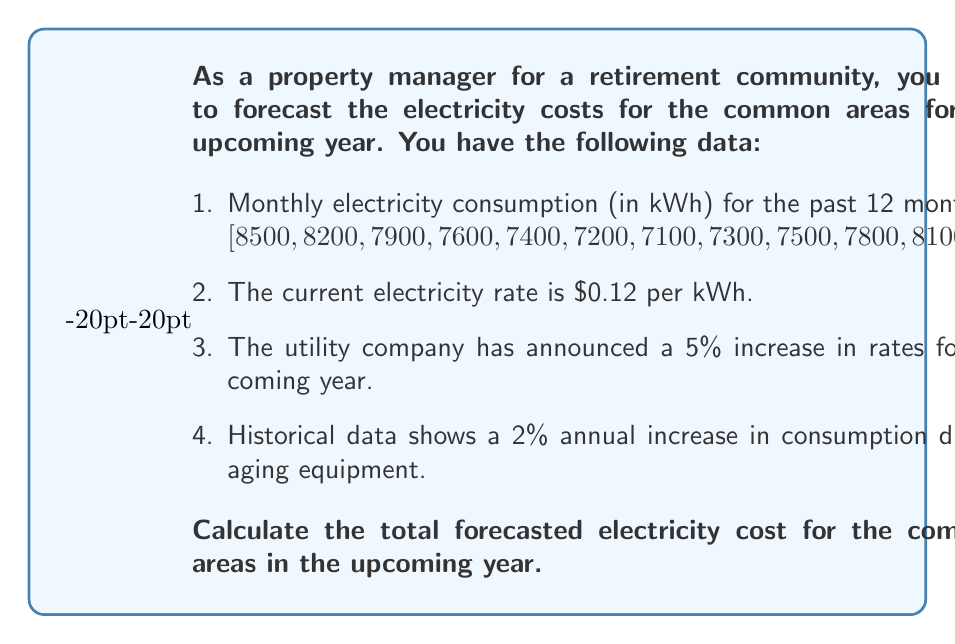Could you help me with this problem? To solve this problem, we'll follow these steps:

1. Calculate the total annual consumption based on the given data.
2. Apply the 2% increase in consumption for the upcoming year.
3. Calculate the new electricity rate after the 5% increase.
4. Compute the total forecasted cost.

Step 1: Calculate the total annual consumption
Total consumption = $\sum_{i=1}^{12} \text{Monthly consumption}_i$
$$ \text{Total consumption} = 8500 + 8200 + 7900 + 7600 + 7400 + 7200 + 7100 + 7300 + 7500 + 7800 + 8100 + 8400 = 93,000 \text{ kWh} $$

Step 2: Apply the 2% increase in consumption
New annual consumption = Current consumption × (1 + 0.02)
$$ \text{New annual consumption} = 93,000 \times 1.02 = 94,860 \text{ kWh} $$

Step 3: Calculate the new electricity rate
New rate = Current rate × (1 + 0.05)
$$ \text{New rate} = \$0.12 \times 1.05 = \$0.126 \text{ per kWh} $$

Step 4: Compute the total forecasted cost
Forecasted cost = New annual consumption × New rate
$$ \text{Forecasted cost} = 94,860 \times \$0.126 = \$11,952.36 $$
Answer: The total forecasted electricity cost for the common areas in the upcoming year is $11,952.36. 